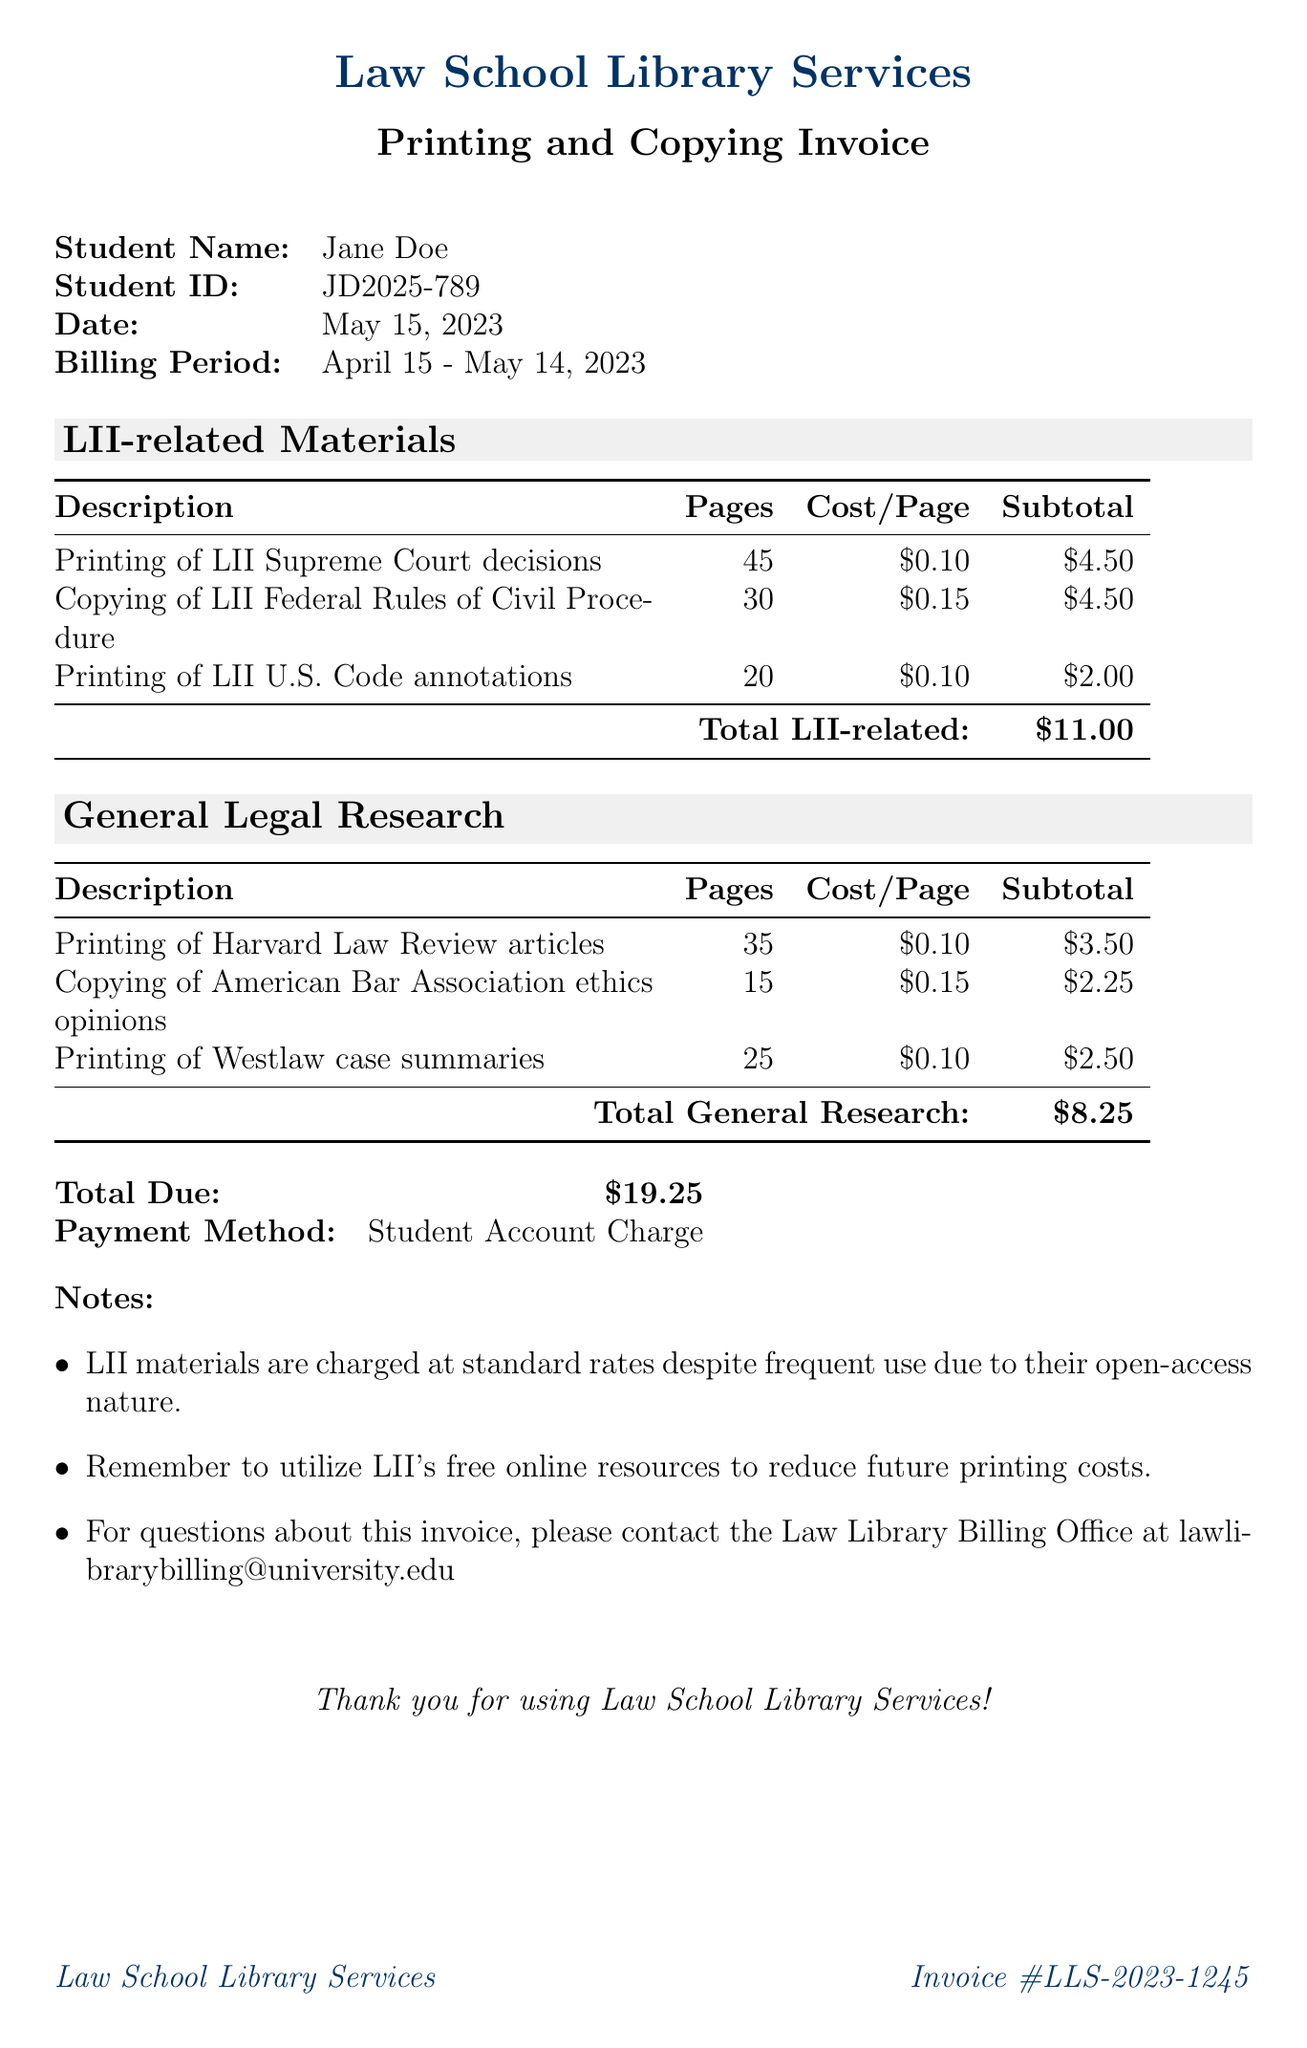what is the invoice number? The invoice number is explicitly listed in the document, referring to this specific billing statement.
Answer: LLS-2023-1245 who is the student associated with this invoice? The document states the name of the student who received the services.
Answer: Jane Doe what is the total due amount? The total due amount is summarized at the end of the document, providing the final balance owed.
Answer: $19.25 how many pages were printed for the LII Supreme Court decisions? The document lists the specific pages printed for each LII-related service, including this one.
Answer: 45 what is the subtotal for LII-related materials? The subtotal for the LII-related materials is calculated and presented within the respective section.
Answer: $11.00 how much was charged for copying the American Bar Association ethics opinions? The invoice details the costs for individual items, which include this copying charge.
Answer: $2.25 during which billing period was this invoice generated? The billing period is specified in the document, providing a timeframe for the services rendered.
Answer: April 15 - May 14, 2023 what payment method was used? The invoice mentions a specific payment method through which the amount will be settled.
Answer: Student Account Charge 